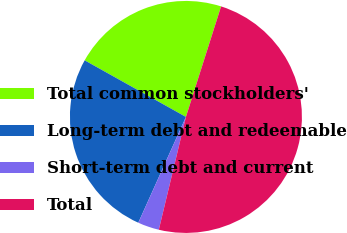Convert chart. <chart><loc_0><loc_0><loc_500><loc_500><pie_chart><fcel>Total common stockholders'<fcel>Long-term debt and redeemable<fcel>Short-term debt and current<fcel>Total<nl><fcel>21.79%<fcel>26.38%<fcel>2.98%<fcel>48.85%<nl></chart> 